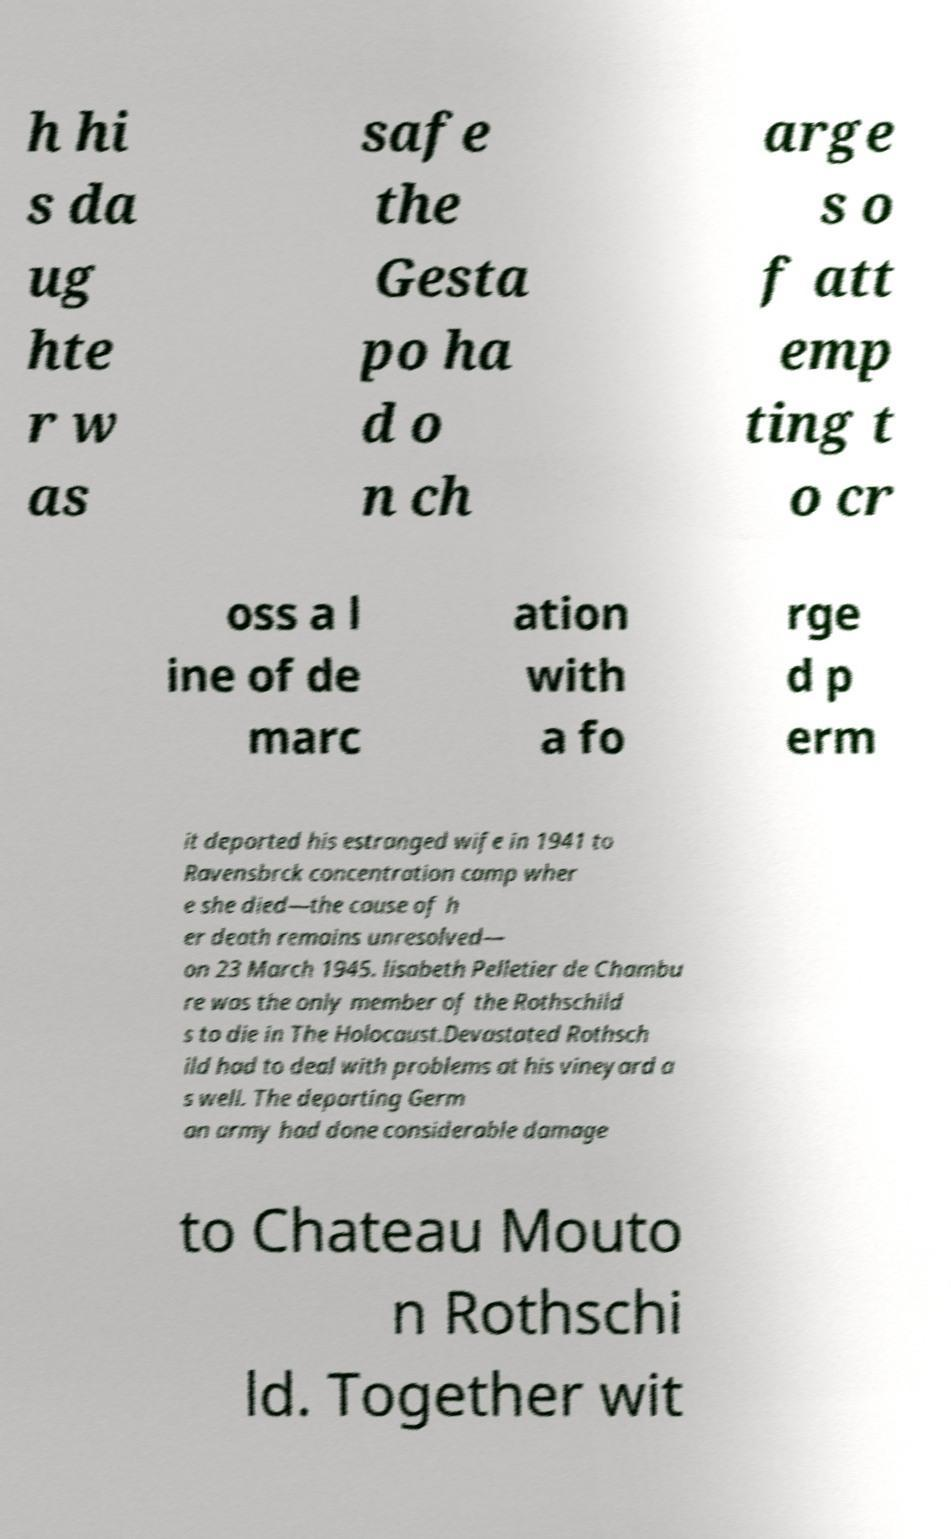There's text embedded in this image that I need extracted. Can you transcribe it verbatim? h hi s da ug hte r w as safe the Gesta po ha d o n ch arge s o f att emp ting t o cr oss a l ine of de marc ation with a fo rge d p erm it deported his estranged wife in 1941 to Ravensbrck concentration camp wher e she died—the cause of h er death remains unresolved— on 23 March 1945. lisabeth Pelletier de Chambu re was the only member of the Rothschild s to die in The Holocaust.Devastated Rothsch ild had to deal with problems at his vineyard a s well. The departing Germ an army had done considerable damage to Chateau Mouto n Rothschi ld. Together wit 